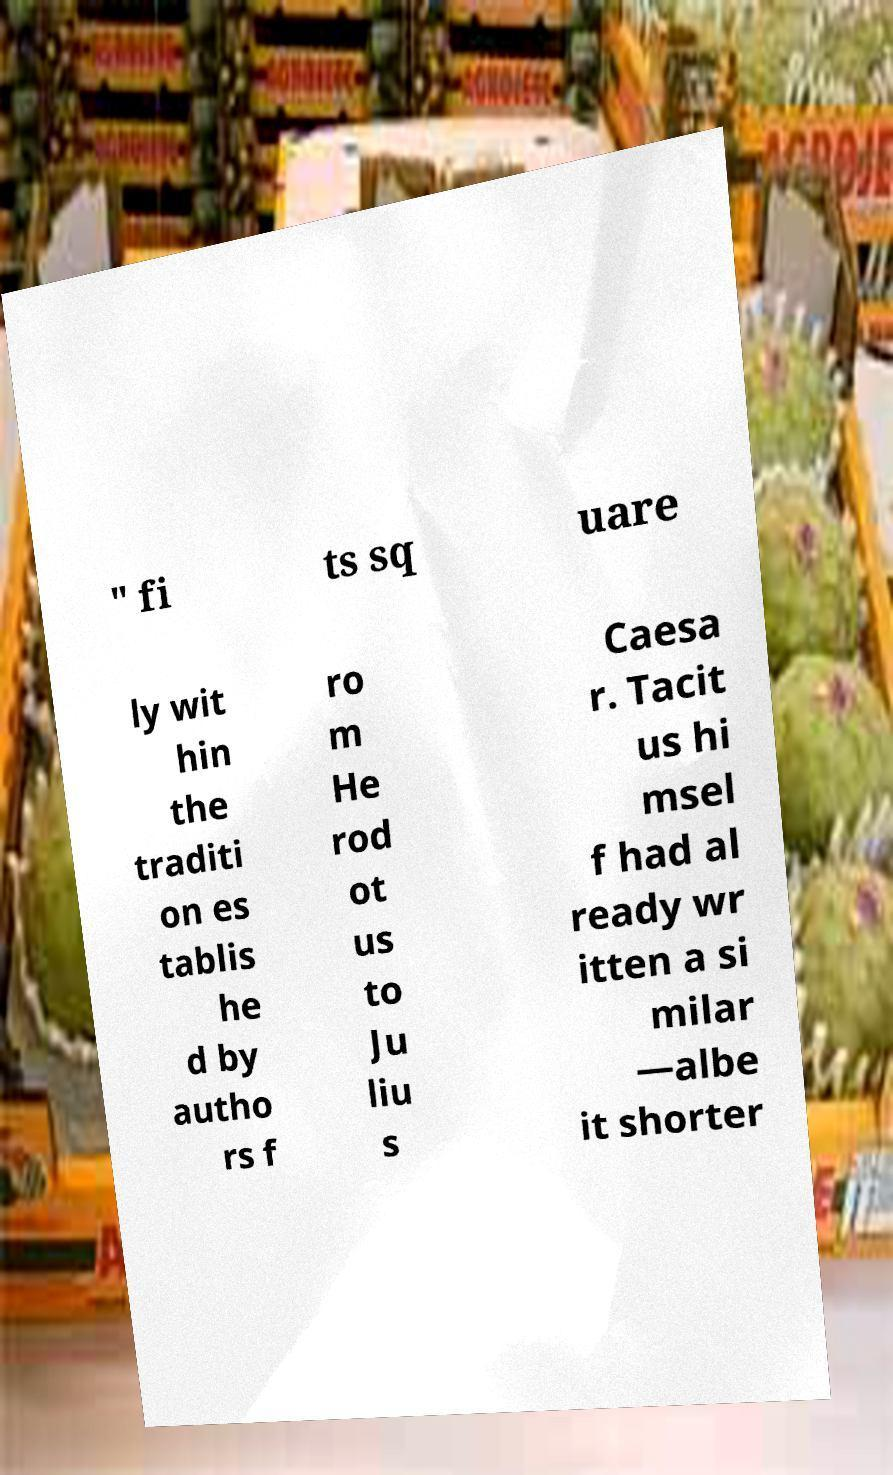What messages or text are displayed in this image? I need them in a readable, typed format. " fi ts sq uare ly wit hin the traditi on es tablis he d by autho rs f ro m He rod ot us to Ju liu s Caesa r. Tacit us hi msel f had al ready wr itten a si milar —albe it shorter 